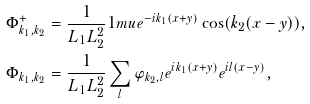Convert formula to latex. <formula><loc_0><loc_0><loc_500><loc_500>\Phi ^ { + } _ { k _ { 1 } , k _ { 2 } } & = \frac { 1 } { L _ { 1 } L _ { 2 } ^ { 2 } } { 1 m u } e ^ { - i k _ { 1 } ( x + y ) } \cos ( k _ { 2 } ( x - y ) ) , \\ \Phi _ { k _ { 1 } , k _ { 2 } } & = \frac { 1 } { L _ { 1 } L _ { 2 } ^ { 2 } } \sum _ { l } \varphi _ { k _ { 2 } , l } e ^ { i k _ { 1 } ( x + y ) } e ^ { i l ( x - y ) } ,</formula> 